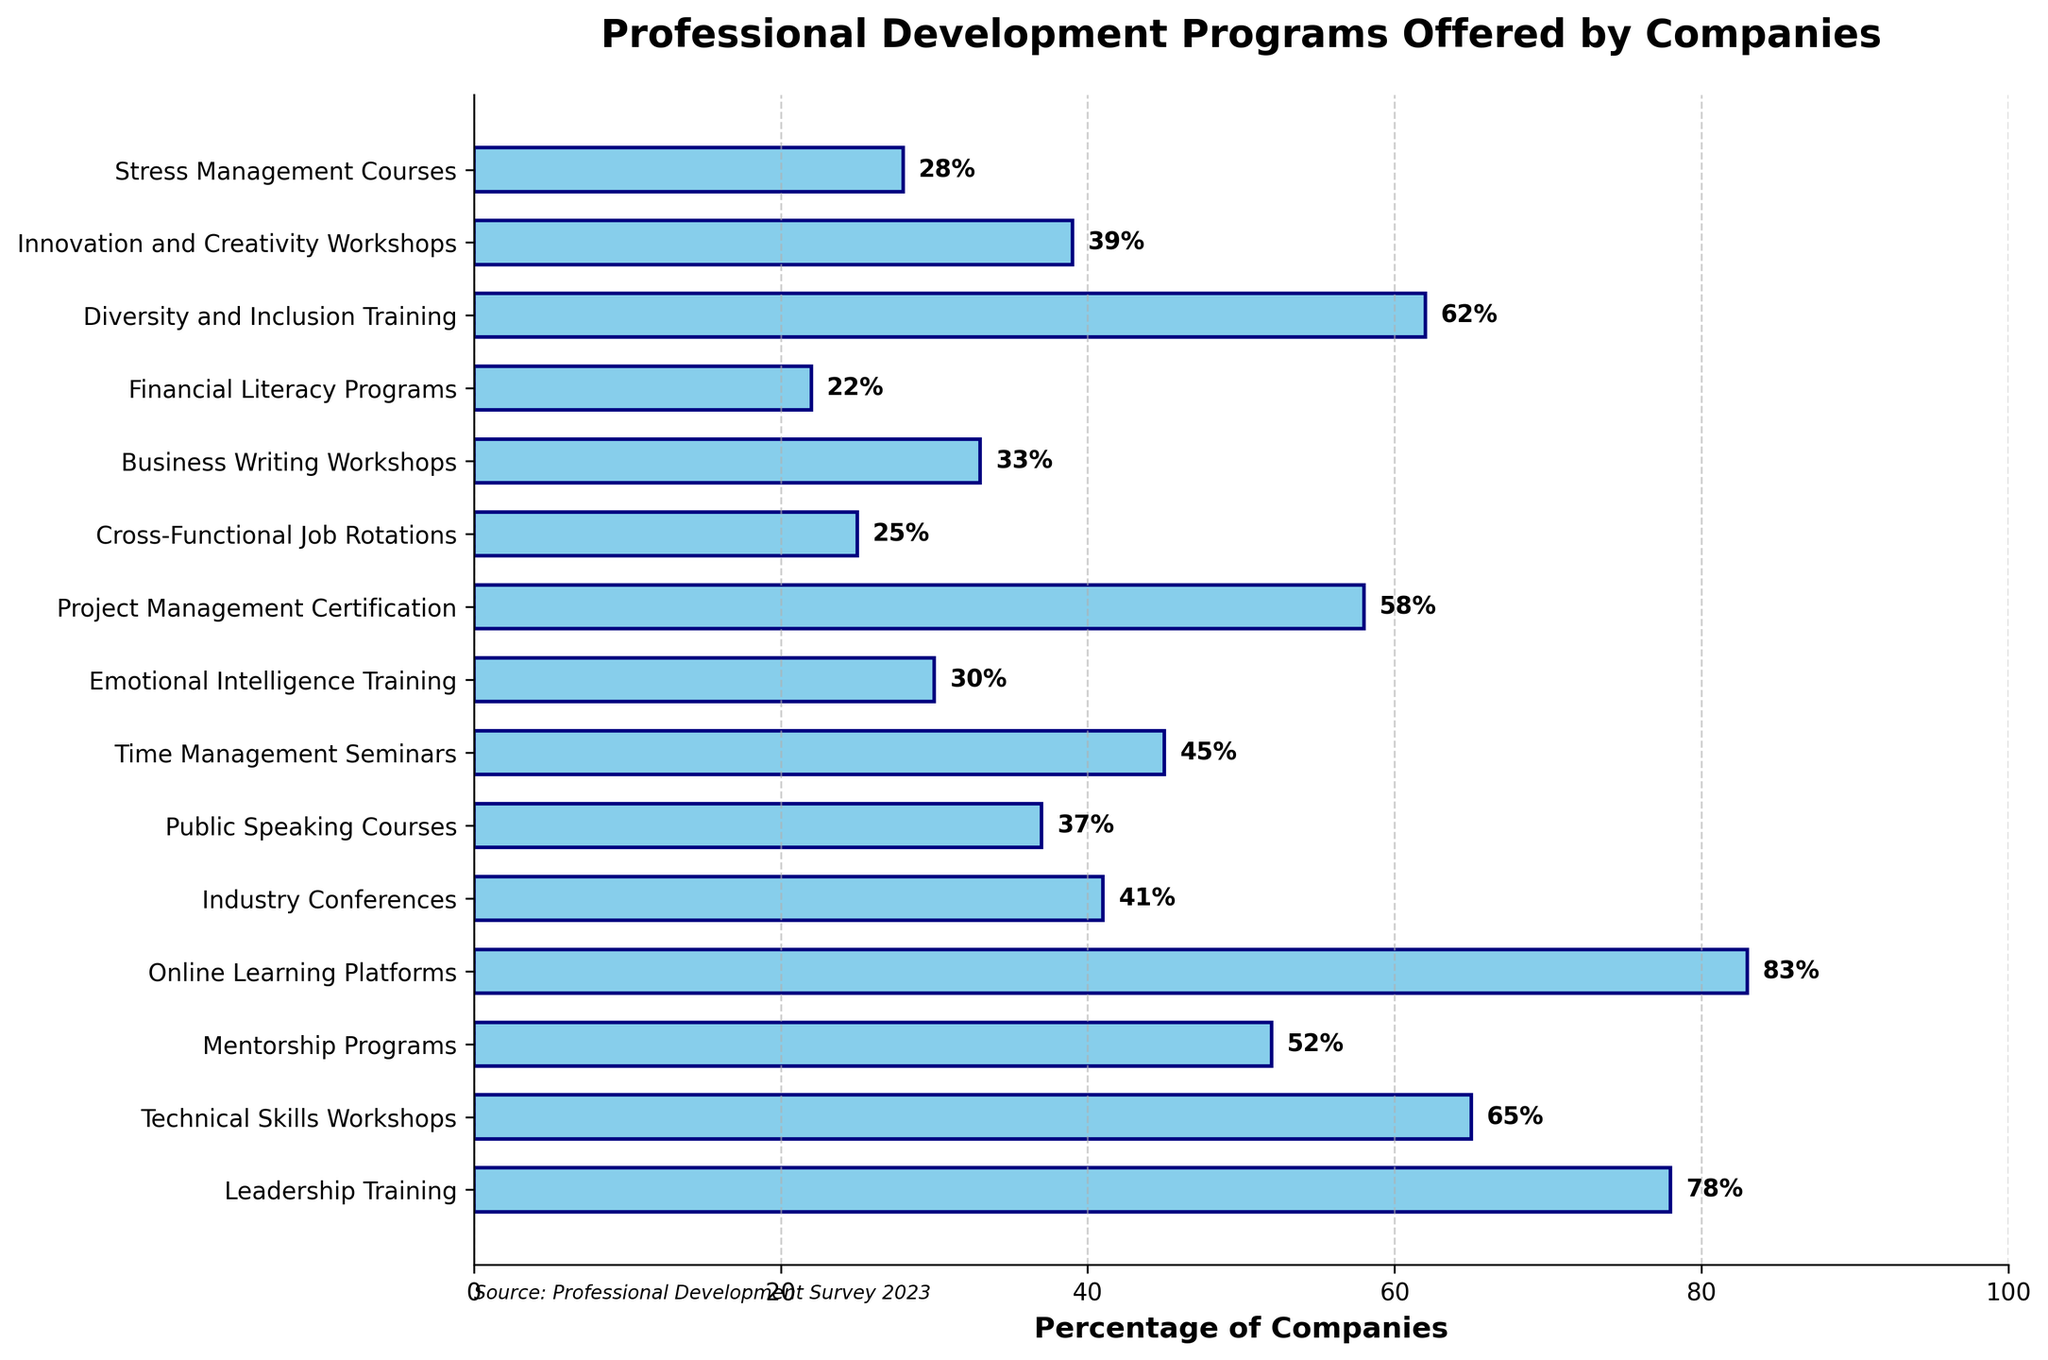What is the most commonly offered professional development program by companies? According to the chart, the "Online Learning Platforms" bar is the longest, indicating it has the highest percentage.
Answer: Online Learning Platforms Which professional development program is least commonly offered by companies? The bar for "Financial Literacy Programs" is the shortest on the chart, showing it has the lowest percentage.
Answer: Financial Literacy Programs How many professional development programs are offered by more than 50% of companies? By examining the bars above the 50% mark, we see that there are five programs: Leadership Training, Technical Skills Workshops, Online Learning Platforms, Project Management Certification, and Diversity and Inclusion Training.
Answer: 5 Which is more commonly offered by companies, Mentorship Programs or Innovation and Creativity Workshops? The bar for "Mentorship Programs" is longer than the bar for "Innovation and Creativity Workshops," indicating it is more commonly offered.
Answer: Mentorship Programs How much less common are Public Speaking Courses compared to Time Management Seminars? Time Management Seminars have a percentage of 45%, and Public Speaking Courses have 37%. The difference is 45% - 37% = 8%.
Answer: 8% What is the median percentage of companies offering the listed professional development programs? Order the percentages: 22, 25, 28, 30, 33, 37, 39, 41, 45, 52, 58, 62, 65, 78, 83. The median is the middle value, which is the 8th value: 41%.
Answer: 41% Which program has a percentage closest to 60%? Looking at the chart, Diversity and Inclusion Training is at 62%, and Project Management Certification is at 58%. Project Management Certification is closer to 60%.
Answer: Project Management Certification What is the sum of the percentages for Emotional Intelligence Training and Stress Management Courses? Emotional Intelligence Training is at 30% and Stress Management Courses are at 28%. Adding them gives 30% + 28% = 58%.
Answer: 58% If a company offers Technical Skills Workshops and Leadership Training, what is the total percentage of companies that potentially offer both? Technical Skills Workshops are at 65% and Leadership Training is at 78%. Summing them gives 65% + 78% = 143%, but this doesn't consider overlaps. For analysis purposes, 143% represents the combined percentage.
Answer: 143% By how much do Industry Conferences exceed Financial Literacy Programs in terms of percentage? The chart shows Industry Conferences at 41% and Financial Literacy Programs at 22%. The difference is 41% - 22% = 19%.
Answer: 19% 